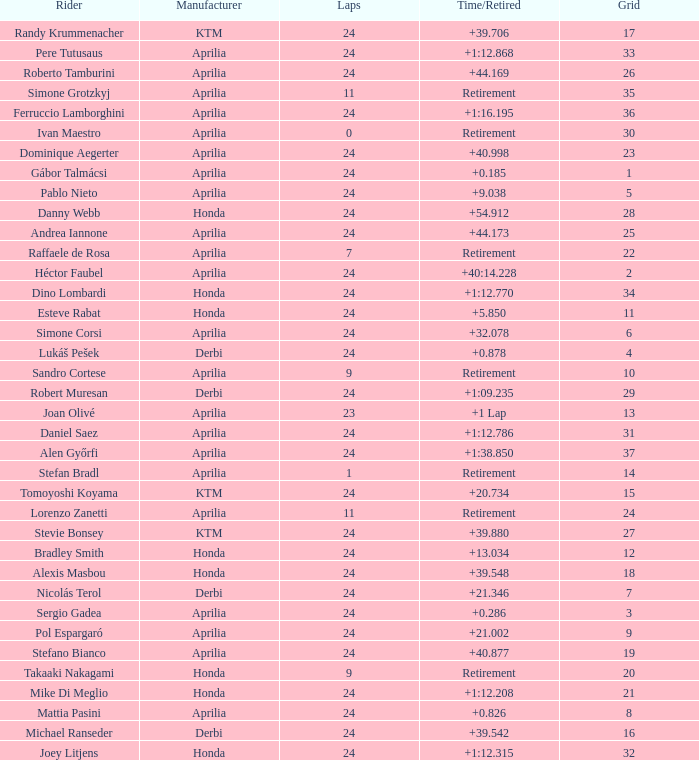How many grids have in excess of 24 laps with a time/retired of +1:1 None. 